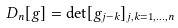<formula> <loc_0><loc_0><loc_500><loc_500>D _ { n } [ g ] = \det [ g _ { j - k } ] _ { j , k = 1 , \dots , n }</formula> 